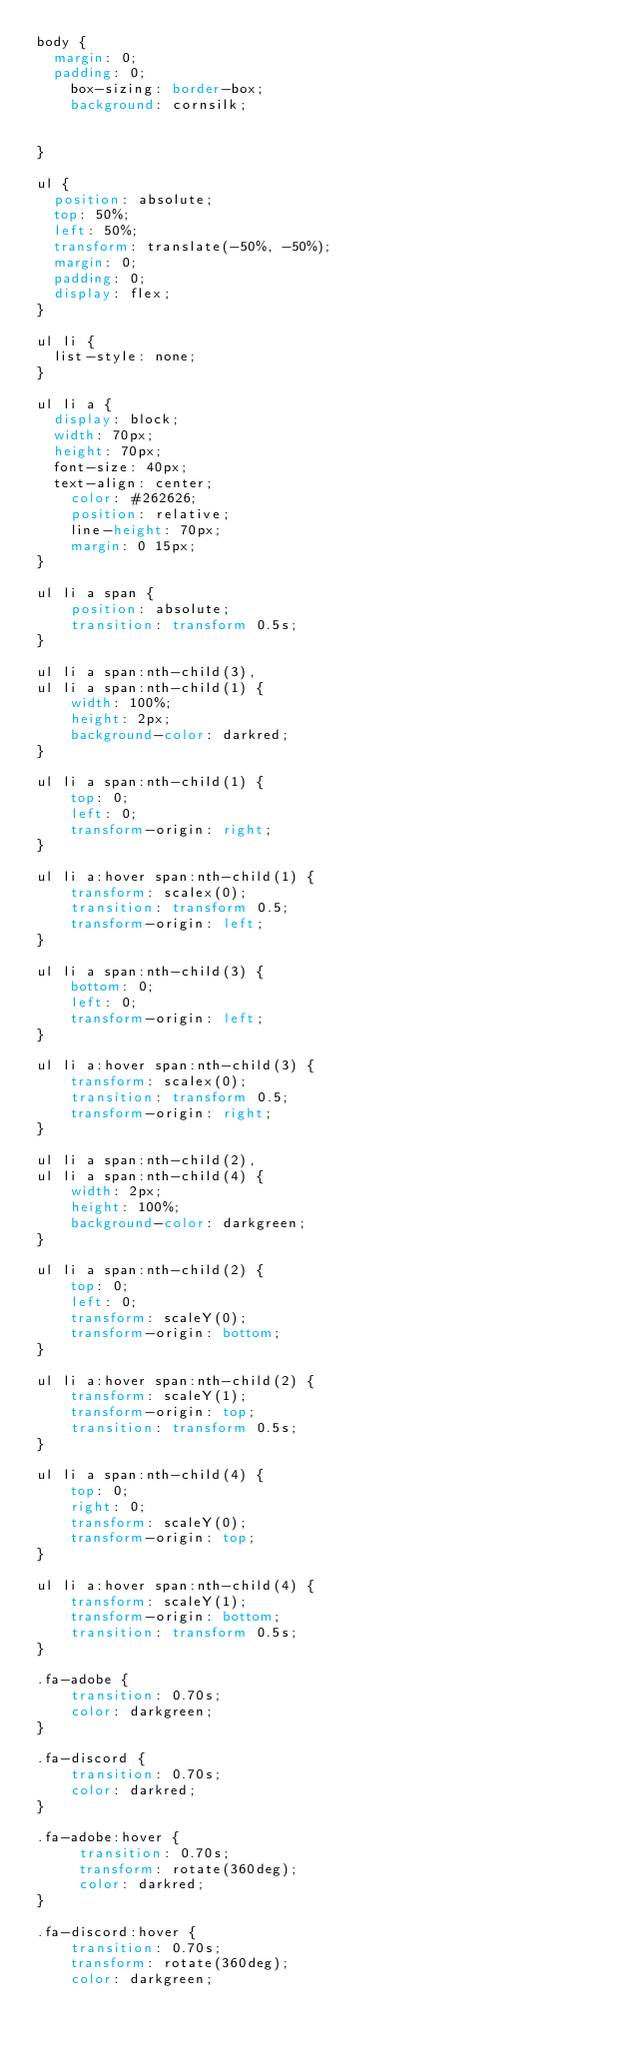<code> <loc_0><loc_0><loc_500><loc_500><_CSS_>body {
	margin: 0;
	padding: 0;
    box-sizing: border-box;
    background: cornsilk;    
    

}

ul {
	position: absolute;
	top: 50%;
	left: 50%;
	transform: translate(-50%, -50%);
	margin: 0;
	padding: 0;
	display: flex;
}

ul li {
	list-style: none;
}

ul li a {
	display: block;
	width: 70px;
	height: 70px;
	font-size: 40px;
	text-align: center;
    color: #262626;
    position: relative;
    line-height: 70px;
    margin: 0 15px;
}

ul li a span {
    position: absolute;
    transition: transform 0.5s;
}

ul li a span:nth-child(3),
ul li a span:nth-child(1) {
    width: 100%;
    height: 2px;
    background-color: darkred;
}

ul li a span:nth-child(1) {
    top: 0;
    left: 0;
    transform-origin: right;
}

ul li a:hover span:nth-child(1) {
    transform: scalex(0);
    transition: transform 0.5;
    transform-origin: left;
}

ul li a span:nth-child(3) {
    bottom: 0;
    left: 0;
    transform-origin: left;
}

ul li a:hover span:nth-child(3) {
    transform: scalex(0);
    transition: transform 0.5;
    transform-origin: right;
}

ul li a span:nth-child(2),
ul li a span:nth-child(4) {
    width: 2px;
    height: 100%;
    background-color: darkgreen;
}

ul li a span:nth-child(2) {
    top: 0;
    left: 0;
    transform: scaleY(0);
    transform-origin: bottom;
}

ul li a:hover span:nth-child(2) {
    transform: scaleY(1);
    transform-origin: top;
    transition: transform 0.5s;
}

ul li a span:nth-child(4) {
    top: 0;
    right: 0;
    transform: scaleY(0);
    transform-origin: top;
}

ul li a:hover span:nth-child(4) {
    transform: scaleY(1);
    transform-origin: bottom;
    transition: transform 0.5s;
}

.fa-adobe {
    transition: 0.70s;
    color: darkgreen; 
}

.fa-discord {
    transition: 0.70s;
    color: darkred;
}

.fa-adobe:hover {
     transition: 0.70s;
     transform: rotate(360deg);
     color: darkred;
}

.fa-discord:hover {
    transition: 0.70s;
    transform: rotate(360deg);
    color: darkgreen;</code> 